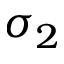Convert formula to latex. <formula><loc_0><loc_0><loc_500><loc_500>\sigma _ { 2 }</formula> 